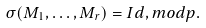Convert formula to latex. <formula><loc_0><loc_0><loc_500><loc_500>\sigma ( M _ { 1 } , \dots , M _ { r } ) = I d , m o d p .</formula> 